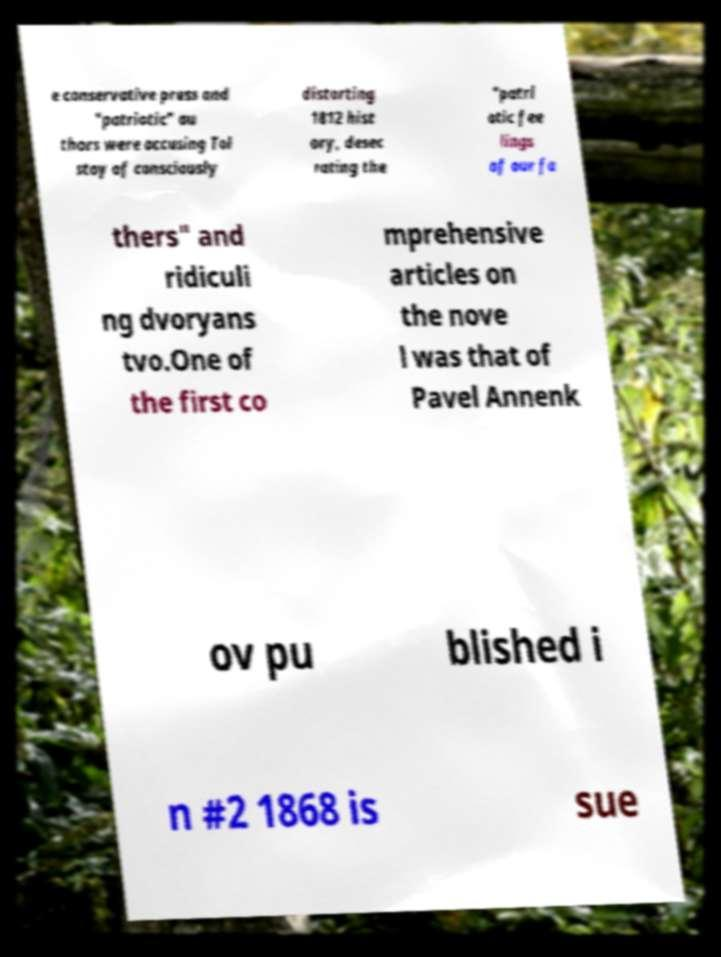Can you accurately transcribe the text from the provided image for me? e conservative press and "patriotic" au thors were accusing Tol stoy of consciously distorting 1812 hist ory, desec rating the "patri otic fee lings of our fa thers" and ridiculi ng dvoryans tvo.One of the first co mprehensive articles on the nove l was that of Pavel Annenk ov pu blished i n #2 1868 is sue 